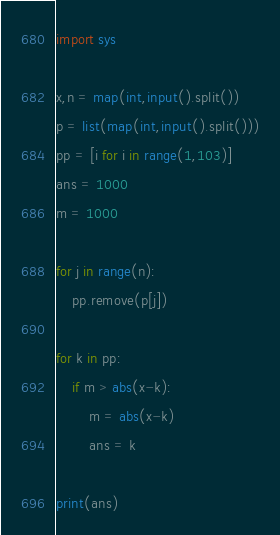<code> <loc_0><loc_0><loc_500><loc_500><_Python_>import sys

x,n = map(int,input().split())
p = list(map(int,input().split()))
pp = [i for i in range(1,103)]
ans = 1000
m = 1000

for j in range(n):
    pp.remove(p[j])

for k in pp:
    if m > abs(x-k):
        m = abs(x-k)
        ans = k

print(ans)</code> 